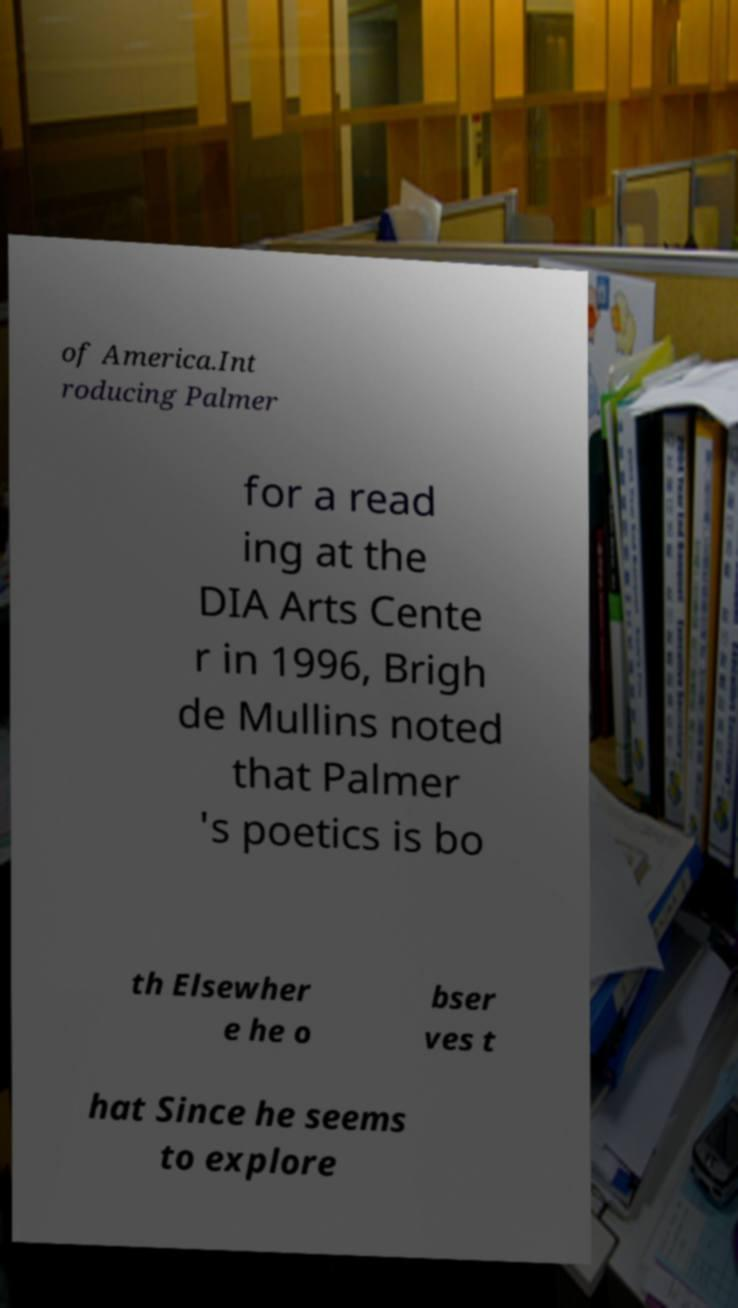Please read and relay the text visible in this image. What does it say? of America.Int roducing Palmer for a read ing at the DIA Arts Cente r in 1996, Brigh de Mullins noted that Palmer 's poetics is bo th Elsewher e he o bser ves t hat Since he seems to explore 